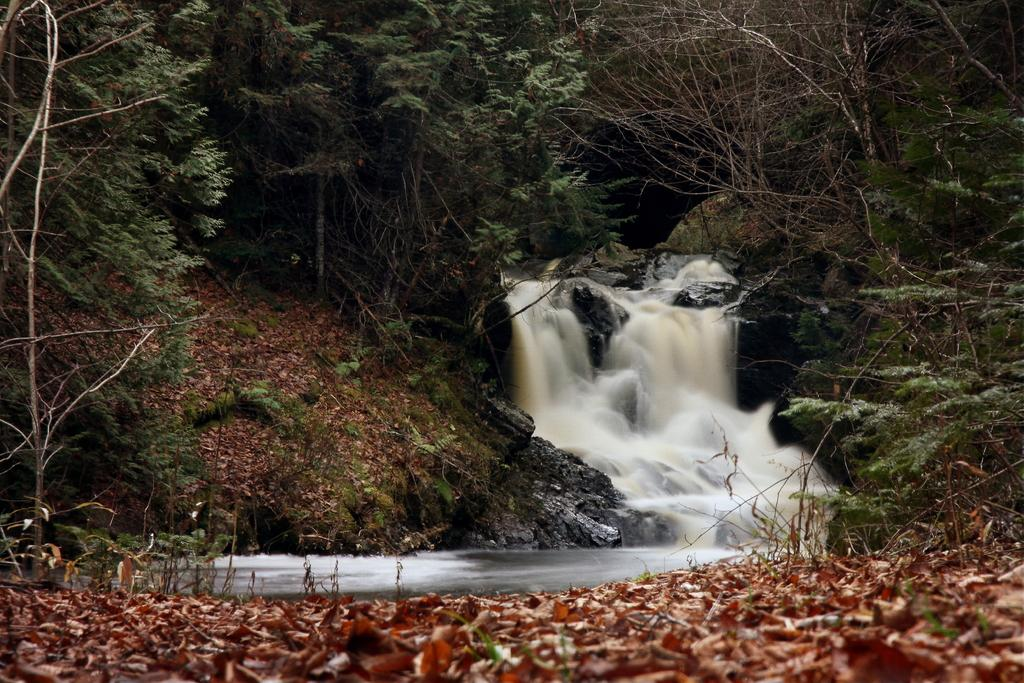What type of vegetation can be seen in the image? There are leaves and trees visible in the image. What else is present in the image besides vegetation? There is water visible in the image. What time of day is depicted in the image? The time of day cannot be determined from the image, as there are no specific indicators of time present. 